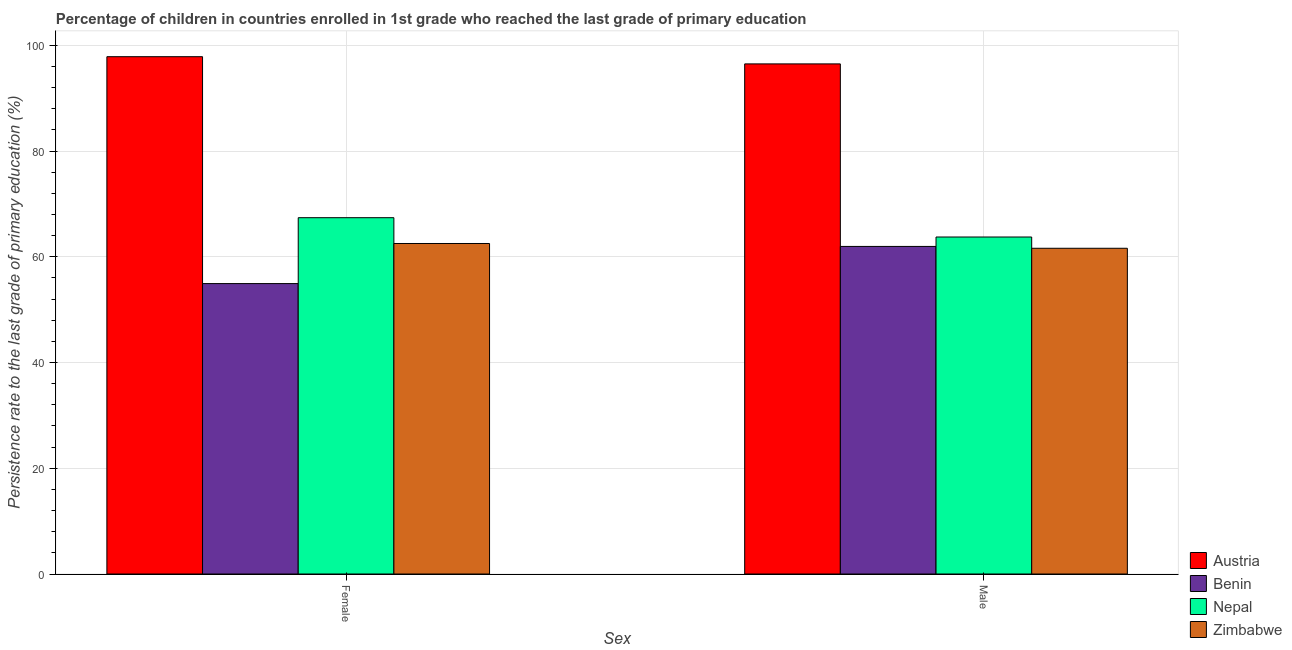How many groups of bars are there?
Your response must be concise. 2. Are the number of bars on each tick of the X-axis equal?
Keep it short and to the point. Yes. How many bars are there on the 1st tick from the left?
Offer a very short reply. 4. What is the label of the 2nd group of bars from the left?
Make the answer very short. Male. What is the persistence rate of male students in Nepal?
Keep it short and to the point. 63.75. Across all countries, what is the maximum persistence rate of female students?
Keep it short and to the point. 97.86. Across all countries, what is the minimum persistence rate of male students?
Offer a terse response. 61.62. In which country was the persistence rate of male students maximum?
Keep it short and to the point. Austria. In which country was the persistence rate of female students minimum?
Provide a succinct answer. Benin. What is the total persistence rate of female students in the graph?
Keep it short and to the point. 282.73. What is the difference between the persistence rate of male students in Benin and that in Zimbabwe?
Offer a terse response. 0.35. What is the difference between the persistence rate of male students in Austria and the persistence rate of female students in Nepal?
Make the answer very short. 29.09. What is the average persistence rate of male students per country?
Give a very brief answer. 70.96. What is the difference between the persistence rate of female students and persistence rate of male students in Benin?
Provide a short and direct response. -7.03. What is the ratio of the persistence rate of male students in Nepal to that in Austria?
Offer a very short reply. 0.66. Is the persistence rate of male students in Austria less than that in Zimbabwe?
Provide a short and direct response. No. What does the 3rd bar from the left in Female represents?
Offer a very short reply. Nepal. What does the 3rd bar from the right in Male represents?
Offer a very short reply. Benin. How many bars are there?
Ensure brevity in your answer.  8. How many countries are there in the graph?
Your answer should be very brief. 4. What is the difference between two consecutive major ticks on the Y-axis?
Make the answer very short. 20. Are the values on the major ticks of Y-axis written in scientific E-notation?
Your answer should be very brief. No. Does the graph contain any zero values?
Your answer should be compact. No. Does the graph contain grids?
Offer a terse response. Yes. How many legend labels are there?
Keep it short and to the point. 4. How are the legend labels stacked?
Provide a short and direct response. Vertical. What is the title of the graph?
Your answer should be compact. Percentage of children in countries enrolled in 1st grade who reached the last grade of primary education. Does "OECD members" appear as one of the legend labels in the graph?
Give a very brief answer. No. What is the label or title of the X-axis?
Provide a succinct answer. Sex. What is the label or title of the Y-axis?
Your answer should be very brief. Persistence rate to the last grade of primary education (%). What is the Persistence rate to the last grade of primary education (%) in Austria in Female?
Your answer should be very brief. 97.86. What is the Persistence rate to the last grade of primary education (%) in Benin in Female?
Give a very brief answer. 54.94. What is the Persistence rate to the last grade of primary education (%) of Nepal in Female?
Make the answer very short. 67.41. What is the Persistence rate to the last grade of primary education (%) in Zimbabwe in Female?
Give a very brief answer. 62.52. What is the Persistence rate to the last grade of primary education (%) of Austria in Male?
Offer a very short reply. 96.5. What is the Persistence rate to the last grade of primary education (%) of Benin in Male?
Ensure brevity in your answer.  61.97. What is the Persistence rate to the last grade of primary education (%) in Nepal in Male?
Ensure brevity in your answer.  63.75. What is the Persistence rate to the last grade of primary education (%) in Zimbabwe in Male?
Your response must be concise. 61.62. Across all Sex, what is the maximum Persistence rate to the last grade of primary education (%) of Austria?
Provide a short and direct response. 97.86. Across all Sex, what is the maximum Persistence rate to the last grade of primary education (%) in Benin?
Offer a very short reply. 61.97. Across all Sex, what is the maximum Persistence rate to the last grade of primary education (%) of Nepal?
Offer a very short reply. 67.41. Across all Sex, what is the maximum Persistence rate to the last grade of primary education (%) of Zimbabwe?
Your answer should be compact. 62.52. Across all Sex, what is the minimum Persistence rate to the last grade of primary education (%) in Austria?
Offer a very short reply. 96.5. Across all Sex, what is the minimum Persistence rate to the last grade of primary education (%) of Benin?
Offer a very short reply. 54.94. Across all Sex, what is the minimum Persistence rate to the last grade of primary education (%) of Nepal?
Your answer should be compact. 63.75. Across all Sex, what is the minimum Persistence rate to the last grade of primary education (%) of Zimbabwe?
Offer a very short reply. 61.62. What is the total Persistence rate to the last grade of primary education (%) in Austria in the graph?
Your answer should be very brief. 194.36. What is the total Persistence rate to the last grade of primary education (%) of Benin in the graph?
Your answer should be very brief. 116.91. What is the total Persistence rate to the last grade of primary education (%) of Nepal in the graph?
Offer a very short reply. 131.16. What is the total Persistence rate to the last grade of primary education (%) in Zimbabwe in the graph?
Your response must be concise. 124.14. What is the difference between the Persistence rate to the last grade of primary education (%) of Austria in Female and that in Male?
Offer a terse response. 1.36. What is the difference between the Persistence rate to the last grade of primary education (%) of Benin in Female and that in Male?
Provide a succinct answer. -7.03. What is the difference between the Persistence rate to the last grade of primary education (%) in Nepal in Female and that in Male?
Give a very brief answer. 3.66. What is the difference between the Persistence rate to the last grade of primary education (%) in Zimbabwe in Female and that in Male?
Make the answer very short. 0.9. What is the difference between the Persistence rate to the last grade of primary education (%) of Austria in Female and the Persistence rate to the last grade of primary education (%) of Benin in Male?
Give a very brief answer. 35.89. What is the difference between the Persistence rate to the last grade of primary education (%) of Austria in Female and the Persistence rate to the last grade of primary education (%) of Nepal in Male?
Your answer should be compact. 34.11. What is the difference between the Persistence rate to the last grade of primary education (%) in Austria in Female and the Persistence rate to the last grade of primary education (%) in Zimbabwe in Male?
Make the answer very short. 36.24. What is the difference between the Persistence rate to the last grade of primary education (%) of Benin in Female and the Persistence rate to the last grade of primary education (%) of Nepal in Male?
Provide a short and direct response. -8.81. What is the difference between the Persistence rate to the last grade of primary education (%) in Benin in Female and the Persistence rate to the last grade of primary education (%) in Zimbabwe in Male?
Provide a short and direct response. -6.68. What is the difference between the Persistence rate to the last grade of primary education (%) of Nepal in Female and the Persistence rate to the last grade of primary education (%) of Zimbabwe in Male?
Your answer should be very brief. 5.78. What is the average Persistence rate to the last grade of primary education (%) of Austria per Sex?
Your answer should be compact. 97.18. What is the average Persistence rate to the last grade of primary education (%) of Benin per Sex?
Give a very brief answer. 58.45. What is the average Persistence rate to the last grade of primary education (%) in Nepal per Sex?
Offer a terse response. 65.58. What is the average Persistence rate to the last grade of primary education (%) in Zimbabwe per Sex?
Offer a terse response. 62.07. What is the difference between the Persistence rate to the last grade of primary education (%) in Austria and Persistence rate to the last grade of primary education (%) in Benin in Female?
Offer a very short reply. 42.92. What is the difference between the Persistence rate to the last grade of primary education (%) in Austria and Persistence rate to the last grade of primary education (%) in Nepal in Female?
Your answer should be compact. 30.46. What is the difference between the Persistence rate to the last grade of primary education (%) of Austria and Persistence rate to the last grade of primary education (%) of Zimbabwe in Female?
Your answer should be very brief. 35.34. What is the difference between the Persistence rate to the last grade of primary education (%) of Benin and Persistence rate to the last grade of primary education (%) of Nepal in Female?
Your answer should be compact. -12.47. What is the difference between the Persistence rate to the last grade of primary education (%) in Benin and Persistence rate to the last grade of primary education (%) in Zimbabwe in Female?
Keep it short and to the point. -7.58. What is the difference between the Persistence rate to the last grade of primary education (%) in Nepal and Persistence rate to the last grade of primary education (%) in Zimbabwe in Female?
Give a very brief answer. 4.88. What is the difference between the Persistence rate to the last grade of primary education (%) in Austria and Persistence rate to the last grade of primary education (%) in Benin in Male?
Keep it short and to the point. 34.53. What is the difference between the Persistence rate to the last grade of primary education (%) in Austria and Persistence rate to the last grade of primary education (%) in Nepal in Male?
Give a very brief answer. 32.75. What is the difference between the Persistence rate to the last grade of primary education (%) of Austria and Persistence rate to the last grade of primary education (%) of Zimbabwe in Male?
Offer a terse response. 34.88. What is the difference between the Persistence rate to the last grade of primary education (%) in Benin and Persistence rate to the last grade of primary education (%) in Nepal in Male?
Provide a short and direct response. -1.78. What is the difference between the Persistence rate to the last grade of primary education (%) in Benin and Persistence rate to the last grade of primary education (%) in Zimbabwe in Male?
Keep it short and to the point. 0.35. What is the difference between the Persistence rate to the last grade of primary education (%) of Nepal and Persistence rate to the last grade of primary education (%) of Zimbabwe in Male?
Offer a very short reply. 2.13. What is the ratio of the Persistence rate to the last grade of primary education (%) in Austria in Female to that in Male?
Your response must be concise. 1.01. What is the ratio of the Persistence rate to the last grade of primary education (%) of Benin in Female to that in Male?
Offer a terse response. 0.89. What is the ratio of the Persistence rate to the last grade of primary education (%) in Nepal in Female to that in Male?
Your answer should be very brief. 1.06. What is the ratio of the Persistence rate to the last grade of primary education (%) of Zimbabwe in Female to that in Male?
Your answer should be compact. 1.01. What is the difference between the highest and the second highest Persistence rate to the last grade of primary education (%) in Austria?
Keep it short and to the point. 1.36. What is the difference between the highest and the second highest Persistence rate to the last grade of primary education (%) in Benin?
Offer a very short reply. 7.03. What is the difference between the highest and the second highest Persistence rate to the last grade of primary education (%) of Nepal?
Your response must be concise. 3.66. What is the difference between the highest and the second highest Persistence rate to the last grade of primary education (%) in Zimbabwe?
Provide a succinct answer. 0.9. What is the difference between the highest and the lowest Persistence rate to the last grade of primary education (%) of Austria?
Provide a succinct answer. 1.36. What is the difference between the highest and the lowest Persistence rate to the last grade of primary education (%) of Benin?
Offer a very short reply. 7.03. What is the difference between the highest and the lowest Persistence rate to the last grade of primary education (%) of Nepal?
Your answer should be very brief. 3.66. What is the difference between the highest and the lowest Persistence rate to the last grade of primary education (%) in Zimbabwe?
Give a very brief answer. 0.9. 